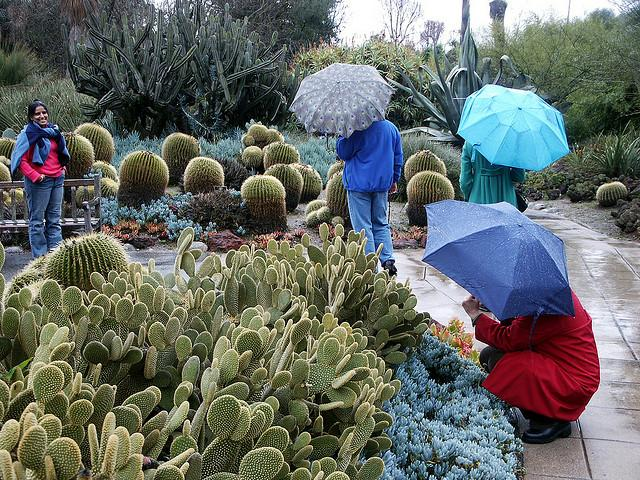These types of plants are good in what environment?

Choices:
A) snowy
B) desert
C) temperate
D) tropical desert 